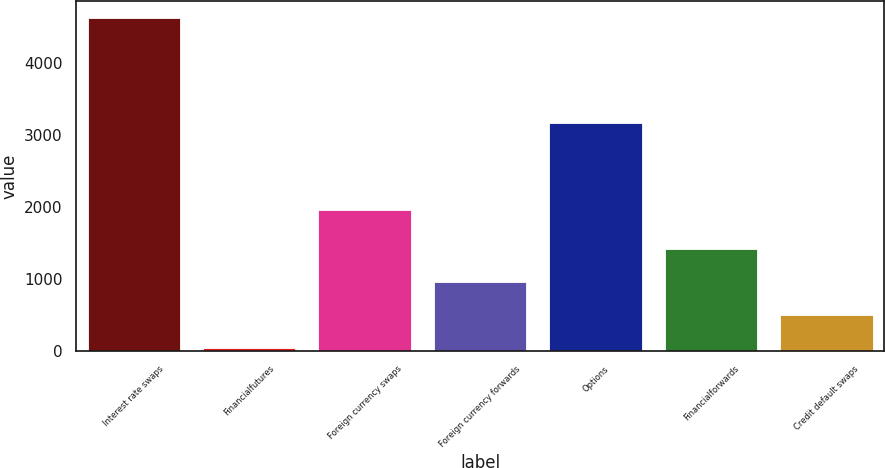Convert chart. <chart><loc_0><loc_0><loc_500><loc_500><bar_chart><fcel>Interest rate swaps<fcel>Financialfutures<fcel>Foreign currency swaps<fcel>Foreign currency forwards<fcel>Options<fcel>Financialforwards<fcel>Credit default swaps<nl><fcel>4617<fcel>45<fcel>1953<fcel>959.4<fcel>3162<fcel>1416.6<fcel>502.2<nl></chart> 